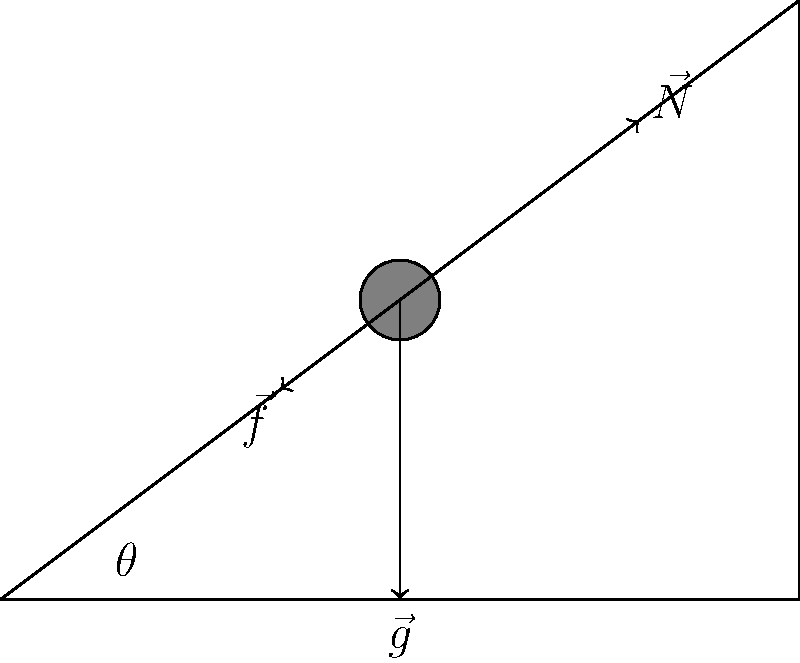In the context of helping individuals with criminal backgrounds readjust to society, consider the following scenario: A person is pushing a heavy box up an inclined plane as part of a rehabilitation program. The box has a mass of 50 kg, and the inclined plane makes an angle of 30° with the horizontal. Given that the coefficient of friction between the box and the plane is 0.2, calculate the magnitude of the force parallel to the inclined plane that the person needs to apply to move the box up the plane at a constant velocity. Let's approach this step-by-step:

1) First, we need to identify the forces acting on the box:
   - Gravity ($\vec{g}$): Acting downward
   - Normal force ($\vec{N}$): Perpendicular to the inclined plane
   - Friction force ($\vec{f}$): Parallel to the plane, opposing motion
   - Applied force ($\vec{F}$): Parallel to the plane, in the direction of motion

2) Calculate the components of the gravitational force:
   - Weight of the box: $W = mg = 50 \text{ kg} \times 9.8 \text{ m/s}^2 = 490 \text{ N}$
   - Component parallel to the plane: $W_{\parallel} = W \sin 30° = 490 \times 0.5 = 245 \text{ N}$
   - Component perpendicular to the plane: $W_{\perp} = W \cos 30° = 490 \times 0.866 = 424.34 \text{ N}$

3) The normal force is equal to the perpendicular component of weight:
   $N = W_{\perp} = 424.34 \text{ N}$

4) Calculate the friction force:
   $f = \mu N = 0.2 \times 424.34 = 84.87 \text{ N}$

5) For constant velocity, the net force along the plane must be zero:
   $F - f - W_{\parallel} = 0$

6) Solve for F:
   $F = f + W_{\parallel} = 84.87 + 245 = 329.87 \text{ N}$

Therefore, the person needs to apply a force of approximately 329.87 N parallel to the inclined plane to move the box at a constant velocity.
Answer: 329.87 N 